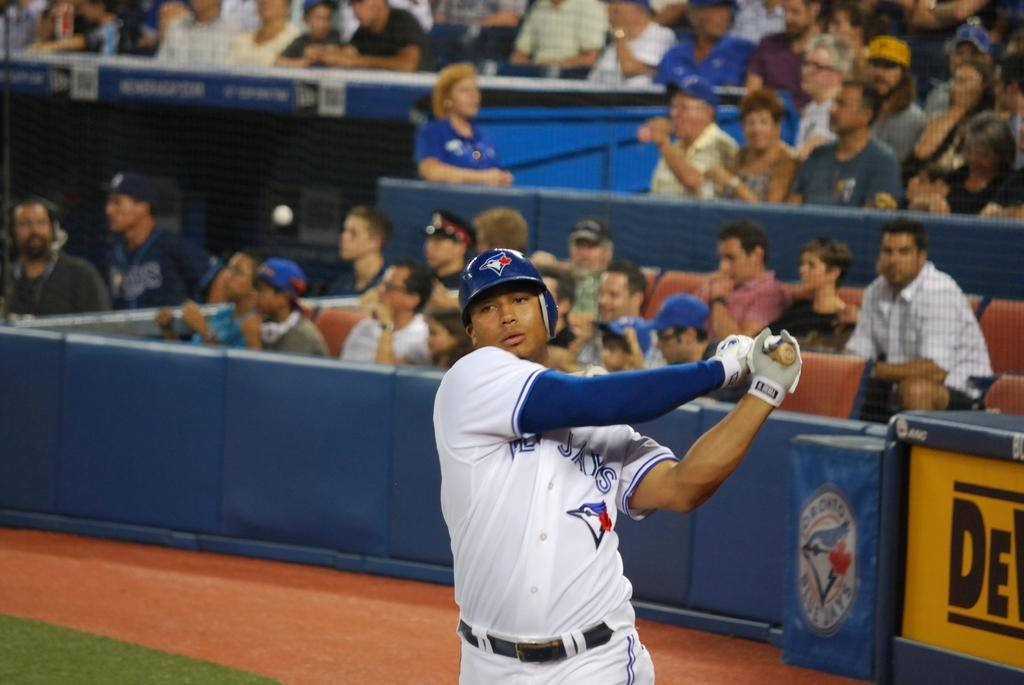Provide a one-sentence caption for the provided image. A player for the Jays swings his bat while wearing a blue helmet. 